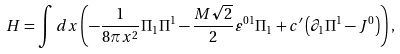<formula> <loc_0><loc_0><loc_500><loc_500>H = \int { d x } \left ( { - \frac { 1 } { 8 \pi x ^ { 2 } } \Pi _ { 1 } \Pi ^ { 1 } - \frac { M \sqrt { 2 } } { 2 } \varepsilon ^ { 0 1 } \Pi _ { 1 } + c ^ { \prime } \left ( { \partial _ { 1 } \Pi ^ { 1 } - J ^ { 0 } } \right ) } \right ) ,</formula> 